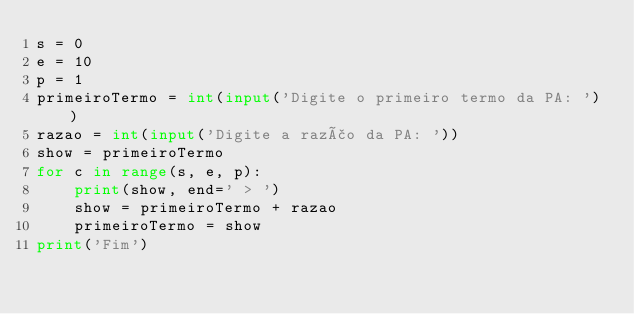<code> <loc_0><loc_0><loc_500><loc_500><_Python_>s = 0
e = 10
p = 1
primeiroTermo = int(input('Digite o primeiro termo da PA: '))
razao = int(input('Digite a razão da PA: '))
show = primeiroTermo
for c in range(s, e, p):
    print(show, end=' > ')
    show = primeiroTermo + razao
    primeiroTermo = show
print('Fim')
</code> 